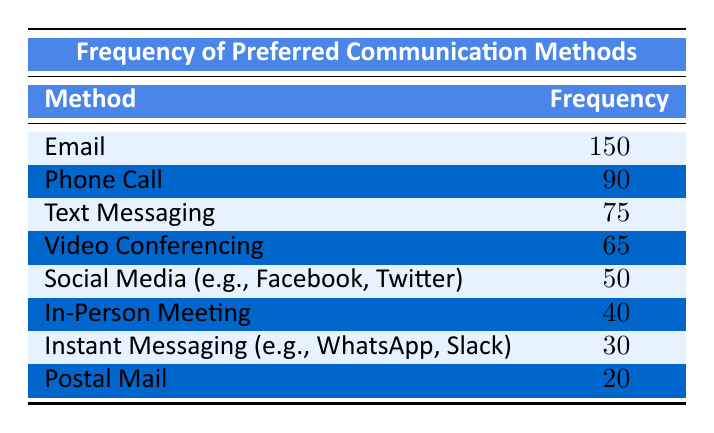What is the most preferred communication method among the survey participants? The most preferred method can be identified by looking for the highest frequency in the table. The method with the highest frequency is Email, which has a frequency of 150.
Answer: Email How many participants preferred Phone Call as a communication method? The table indicates that the frequency for Phone Call is listed as 90, which directly answers the question.
Answer: 90 Which two communication methods have the lowest frequencies, and what are their values? To find the two lowest frequencies, I review the table and identify the last two methods listed. These are Instant Messaging with a frequency of 30 and Postal Mail with a frequency of 20.
Answer: Instant Messaging (30), Postal Mail (20) What is the total frequency of all preferred communication methods listed in the table? To calculate the total frequency, I sum the frequencies of all methods: 150 + 90 + 75 + 65 + 50 + 40 + 30 + 20 = 520. Therefore, the total is 520.
Answer: 520 Is it true that more participants preferred Video Conferencing than In-Person Meeting? By comparing the frequencies in the table, Video Conferencing has a frequency of 65 and In-Person Meeting has a frequency of 40. Since 65 is greater than 40, the statement is true.
Answer: Yes What is the difference in frequency between the most preferred method and the least preferred method? The most preferred method, Email, has a frequency of 150, and the least preferred method, Postal Mail, has a frequency of 20. The difference is calculated by subtracting the least from the most: 150 - 20 = 130.
Answer: 130 What is the average frequency of preferred communication methods? To find the average, I total the frequencies (520 from a previous calculation) and divide by the number of methods listed, which is 8: 520 / 8 = 65. Thus, the average frequency is 65.
Answer: 65 Which method has more participants preferring it: Social Media or Text Messaging? Looking at the table, Social Media has a frequency of 50 while Text Messaging has 75. Since 50 is less than 75, Text Messaging is preferred by more participants.
Answer: Text Messaging How many communication methods have a frequency greater than 40? Referring to the table, I count the methods with a frequency greater than 40. Those are Email (150), Phone Call (90), Text Messaging (75), and Video Conferencing (65). There are four methods that meet this criterion.
Answer: 4 